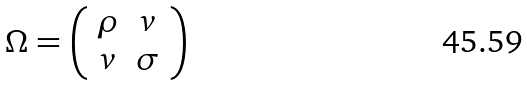Convert formula to latex. <formula><loc_0><loc_0><loc_500><loc_500>\Omega = \left ( \begin{array} { c c } \rho & v \\ v & \sigma \\ \end{array} \right )</formula> 